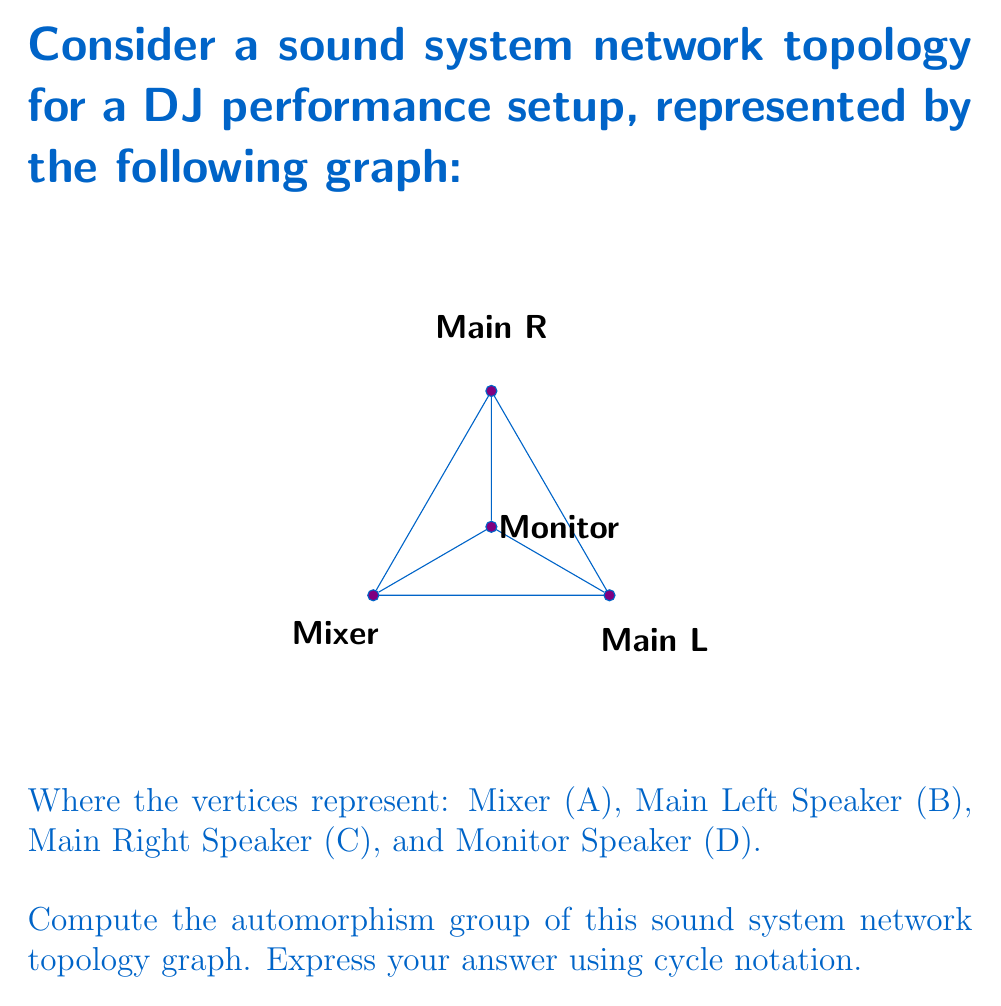Provide a solution to this math problem. To find the automorphism group of this graph, we need to determine all the symmetries that preserve the graph structure. Let's approach this step-by-step:

1) First, observe the degree of each vertex:
   - Mixer (A): degree 3
   - Main Left (B): degree 3
   - Main Right (C): degree 3
   - Monitor (D): degree 3

2) All vertices have the same degree, so potentially any vertex could be mapped to any other vertex.

3) However, we need to preserve the edge structure. Notice that:
   - A, B, and C form a triangle
   - D is connected to all vertices of this triangle

4) The only non-trivial symmetry of this graph is the reflection that swaps B and C (the main speakers) while keeping A and D fixed.

5) Therefore, the automorphism group consists of two elements:
   - The identity automorphism: $(A)(B)(C)(D)$
   - The automorphism that swaps B and C: $(A)(BC)(D)$

6) This group is isomorphic to the cyclic group of order 2, $C_2$ or $\mathbb{Z}_2$.

In cycle notation, we represent this group as:

$$ \{(A)(B)(C)(D), (A)(BC)(D)\} $$

This is the automorphism group of the sound system network topology.
Answer: $$ \{(A)(B)(C)(D), (A)(BC)(D)\} $$ 